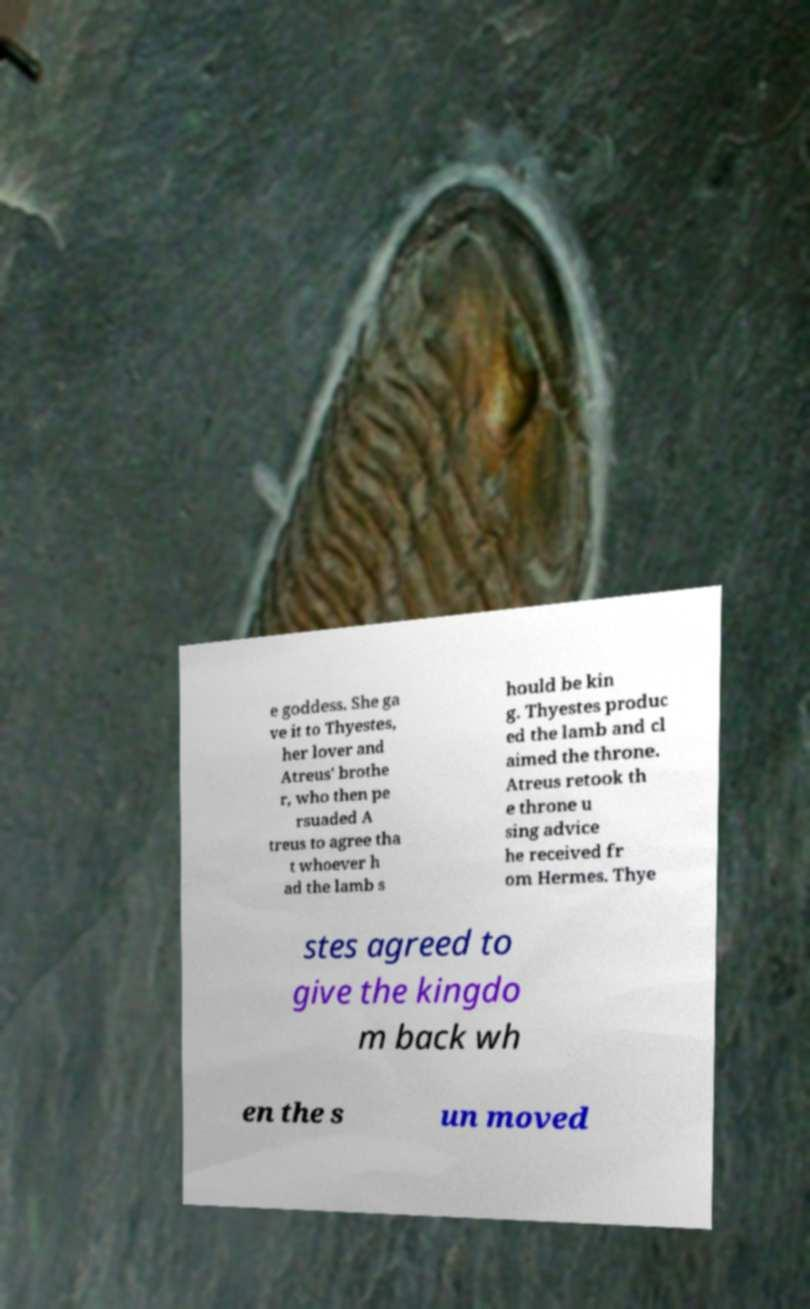Can you accurately transcribe the text from the provided image for me? e goddess. She ga ve it to Thyestes, her lover and Atreus' brothe r, who then pe rsuaded A treus to agree tha t whoever h ad the lamb s hould be kin g. Thyestes produc ed the lamb and cl aimed the throne. Atreus retook th e throne u sing advice he received fr om Hermes. Thye stes agreed to give the kingdo m back wh en the s un moved 